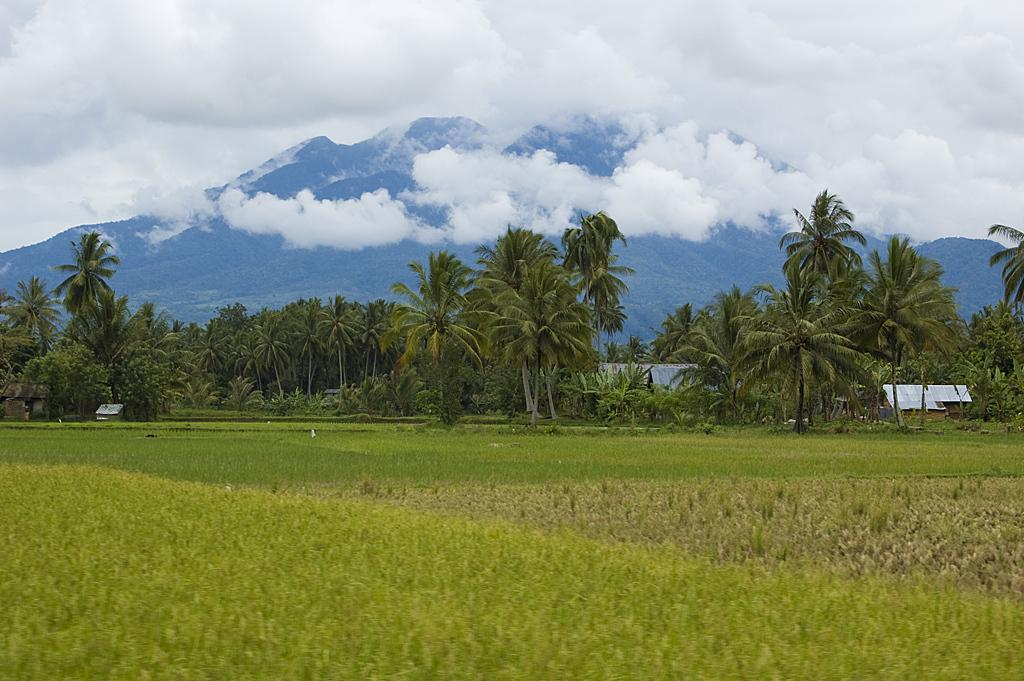What type of vegetation can be seen in the image? There are trees in the image. What type of structures are visible in the image? There are houses in the image. What is the ground covered with in the image? There is grass in the image. What type of natural formation can be seen in the image? There are mountains in the image. What is visible in the background of the image? The sky is visible in the background of the image. What can be seen in the sky in the image? Clouds are present in the sky. What is the opinion of the trees about the houses in the image? Trees do not have opinions, as they are inanimate objects. How many eyes can be seen on the mountains in the image? Mountains do not have eyes, as they are geological formations. 